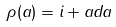<formula> <loc_0><loc_0><loc_500><loc_500>\rho ( a ) = i + a d a</formula> 